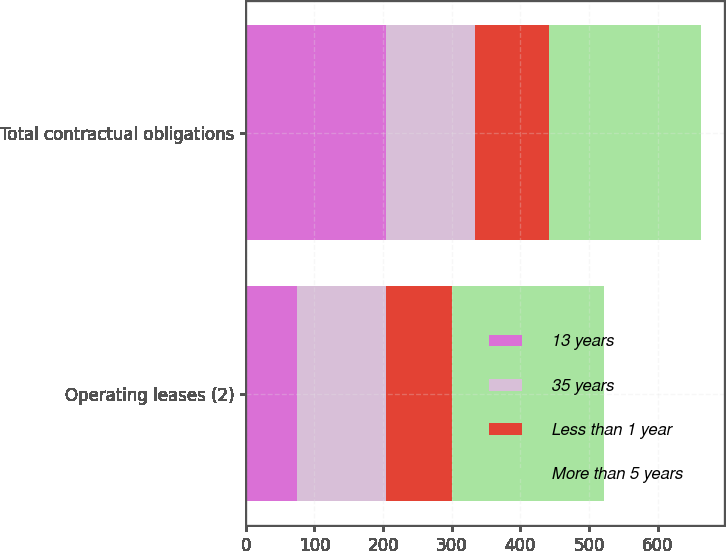Convert chart to OTSL. <chart><loc_0><loc_0><loc_500><loc_500><stacked_bar_chart><ecel><fcel>Operating leases (2)<fcel>Total contractual obligations<nl><fcel>13 years<fcel>74<fcel>204<nl><fcel>35 years<fcel>130<fcel>130<nl><fcel>Less than 1 year<fcel>97<fcel>107<nl><fcel>More than 5 years<fcel>221<fcel>222<nl></chart> 